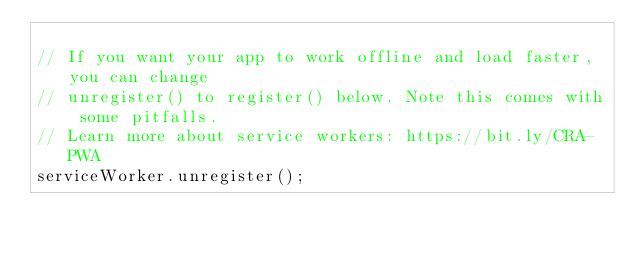Convert code to text. <code><loc_0><loc_0><loc_500><loc_500><_JavaScript_>
// If you want your app to work offline and load faster, you can change
// unregister() to register() below. Note this comes with some pitfalls.
// Learn more about service workers: https://bit.ly/CRA-PWA
serviceWorker.unregister();
</code> 